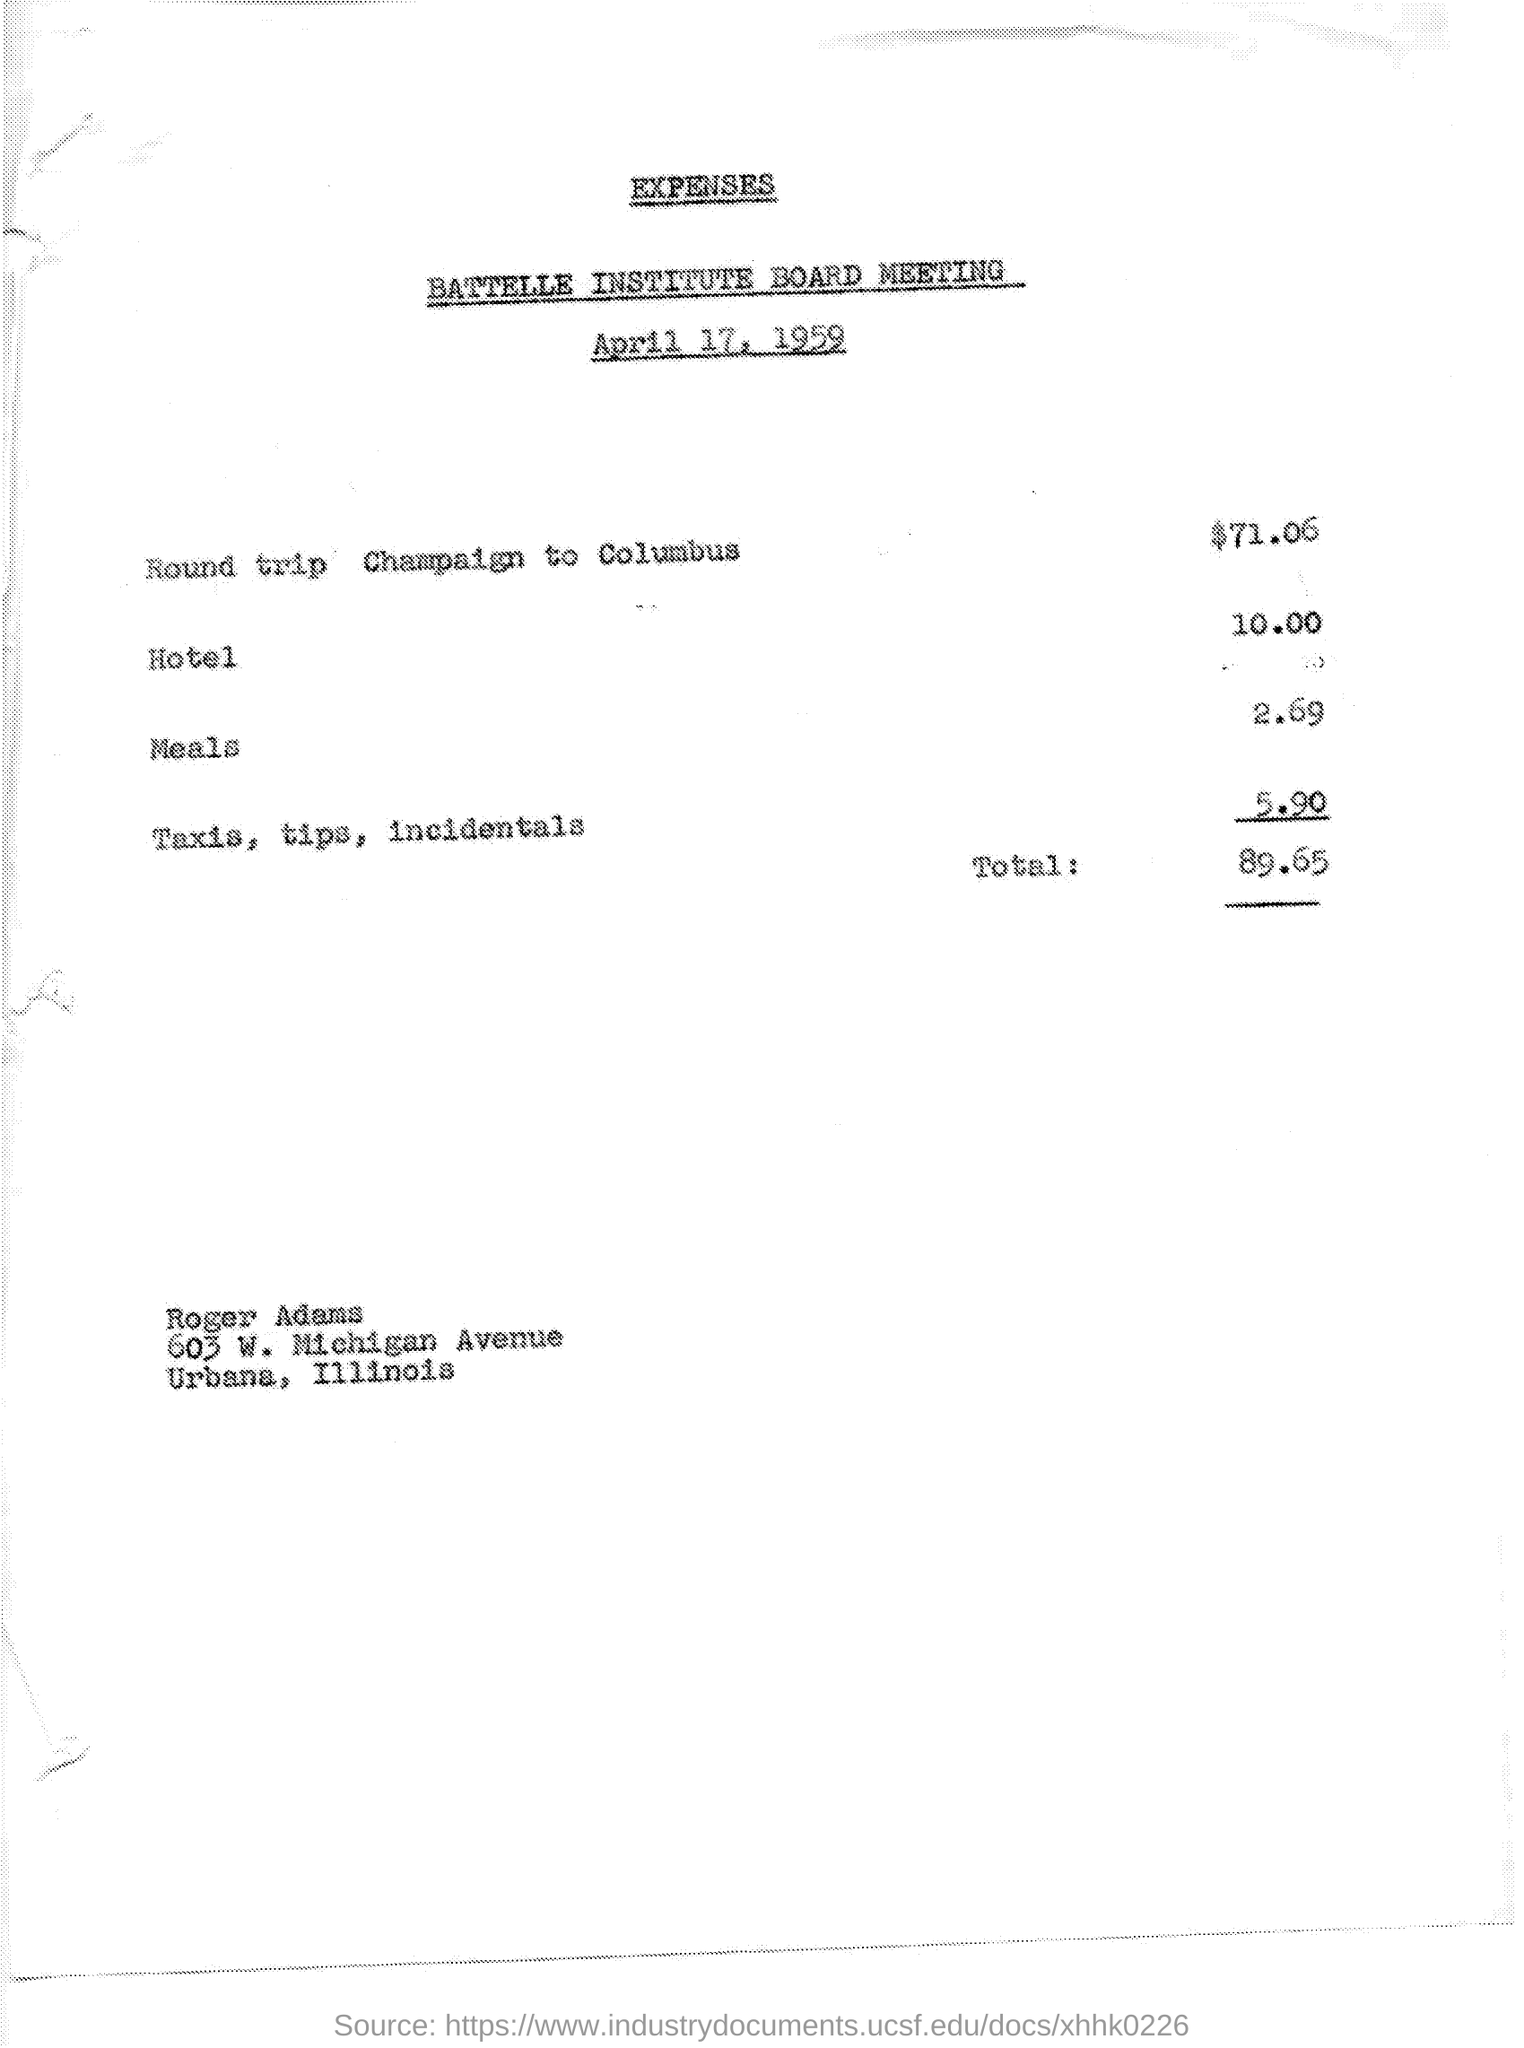What is the date on the document?
Ensure brevity in your answer.  April 17, 1959. What is the cost for Taxis,tips , incidentals?
Your answer should be very brief. 5.90. What is the cost for Round trip Champaign to Columbus?
Provide a short and direct response. $71.06. What is the cost for Hotel?
Make the answer very short. 10.00. What is the cost for Meals?
Provide a short and direct response. 2.69. What is the Total?
Your answer should be compact. 89.65. 